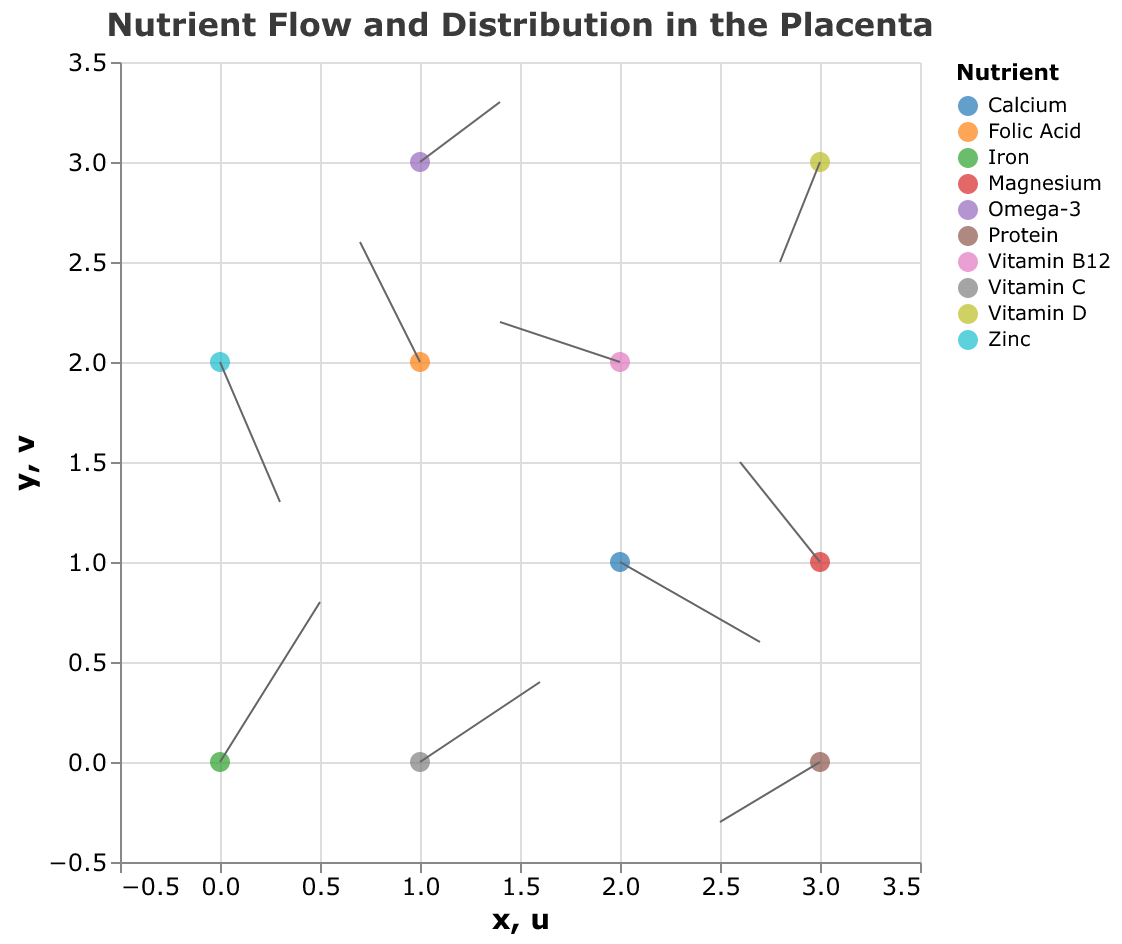What is the title of the plot? The plot's title is clearly displayed at the top of the figure. It indicates the main subject of the visualization.
Answer: Nutrient Flow and Distribution in the Placenta Which nutrient has the vector starting at position (2,1)? Locate the coordinate (2,1) on the plot and check the corresponding vector. The tooltip or legend can help identify the nutrient associated with that vector.
Answer: Calcium How many nutrients are shown in the plot? Count the unique nutrient names listed in the legend or identifiable through the plot's color-coded points.
Answer: 10 Which nutrient has the highest vector magnitude and what is its value? Calculate the vector magnitudes (sqrt(u^2 + v^2)) for each nutrient. The highest magnitude can be derived from these calculations.
Answer: Iron, 0.94 What is the direction of the vector for Folic Acid? Determine the vector direction by checking the u and v components at the position corresponding to Folic Acid. The direction is defined by its components.
Answer: Left-Up Which nutrient has a negative u and positive v component, and what are those components? Inspect the vectors that have negative u and positive v components by checking each vector from the data points.
Answer: Folic Acid, u = -0.3, v = 0.6 Which nutrient flows towards the top-right direction and what is its starting position? Identify the vectors whose u and v components are both positive, indicating a top-right direction. Then, locate their starting positions.
Answer: Iron, (0,0) Compare the vector magnitudes between Vitamin C and Protein. Which one is larger and by how much? Calculate magnitudes for Vitamin C (sqrt(0.6^2 + 0.4^2)) and Protein (sqrt(-0.5^2 + -0.3^2)). Subtract the smaller magnitude from the larger one to find the difference.
Answer: Vitamin C is larger by approximately 0.36 What are the coordinates of the starting and ending points of the vector for Omega-3? Identify the starting point (1,3) from the data. Calculate the end point by adding the u and v components to the starting coordinates (1+0.4, 3+0.3).
Answer: Starting: (1,3), Ending: (1.4,3.3) How many nutrients have vectors moving in the negative y-direction? Name them. Check the y-components (v) of all vectors to count and list the vectors with negative values.
Answer: Three: Calcium, Vitamin D, Zinc 